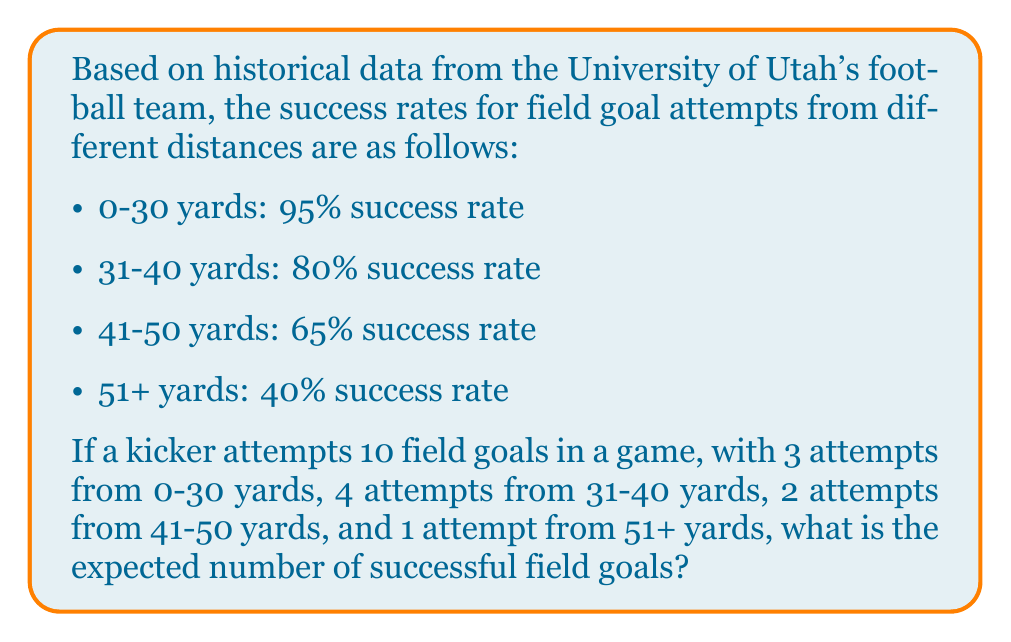What is the answer to this math problem? To solve this problem, we'll use the concept of expected value from statistical mechanics. The expected value is calculated by multiplying each possible outcome by its probability and then summing these products.

Let's break it down step-by-step:

1. For 0-30 yard attempts:
   - Number of attempts = 3
   - Success rate = 95% = 0.95
   - Expected successful attempts = $3 \times 0.95 = 2.85$

2. For 31-40 yard attempts:
   - Number of attempts = 4
   - Success rate = 80% = 0.80
   - Expected successful attempts = $4 \times 0.80 = 3.20$

3. For 41-50 yard attempts:
   - Number of attempts = 2
   - Success rate = 65% = 0.65
   - Expected successful attempts = $2 \times 0.65 = 1.30$

4. For 51+ yard attempts:
   - Number of attempts = 1
   - Success rate = 40% = 0.40
   - Expected successful attempts = $1 \times 0.40 = 0.40$

5. Calculate the total expected number of successful field goals:
   $$E(\text{successful field goals}) = 2.85 + 3.20 + 1.30 + 0.40 = 7.75$$

Therefore, the expected number of successful field goals is 7.75.
Answer: 7.75 successful field goals 